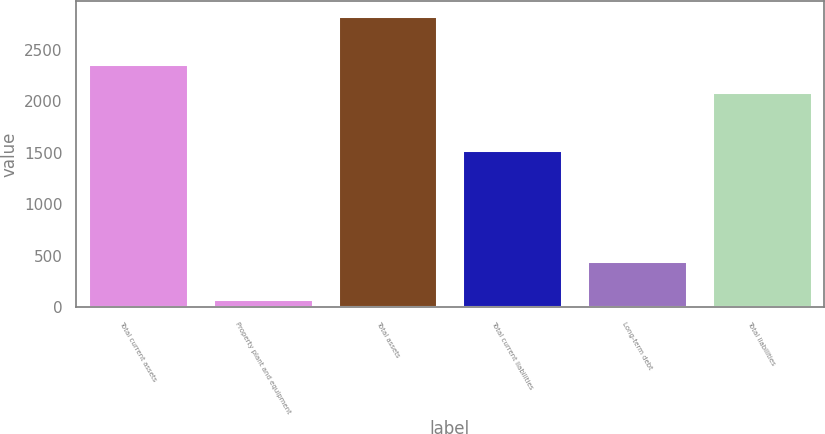Convert chart. <chart><loc_0><loc_0><loc_500><loc_500><bar_chart><fcel>Total current assets<fcel>Property plant and equipment<fcel>Total assets<fcel>Total current liabilities<fcel>Long-term debt<fcel>Total liabilities<nl><fcel>2362.9<fcel>82.6<fcel>2833.6<fcel>1532.2<fcel>447.9<fcel>2087.8<nl></chart> 